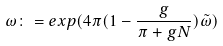<formula> <loc_0><loc_0><loc_500><loc_500>\omega \colon = e x p ( 4 \pi ( 1 - \frac { g } { \pi + g N } ) \tilde { \omega } )</formula> 